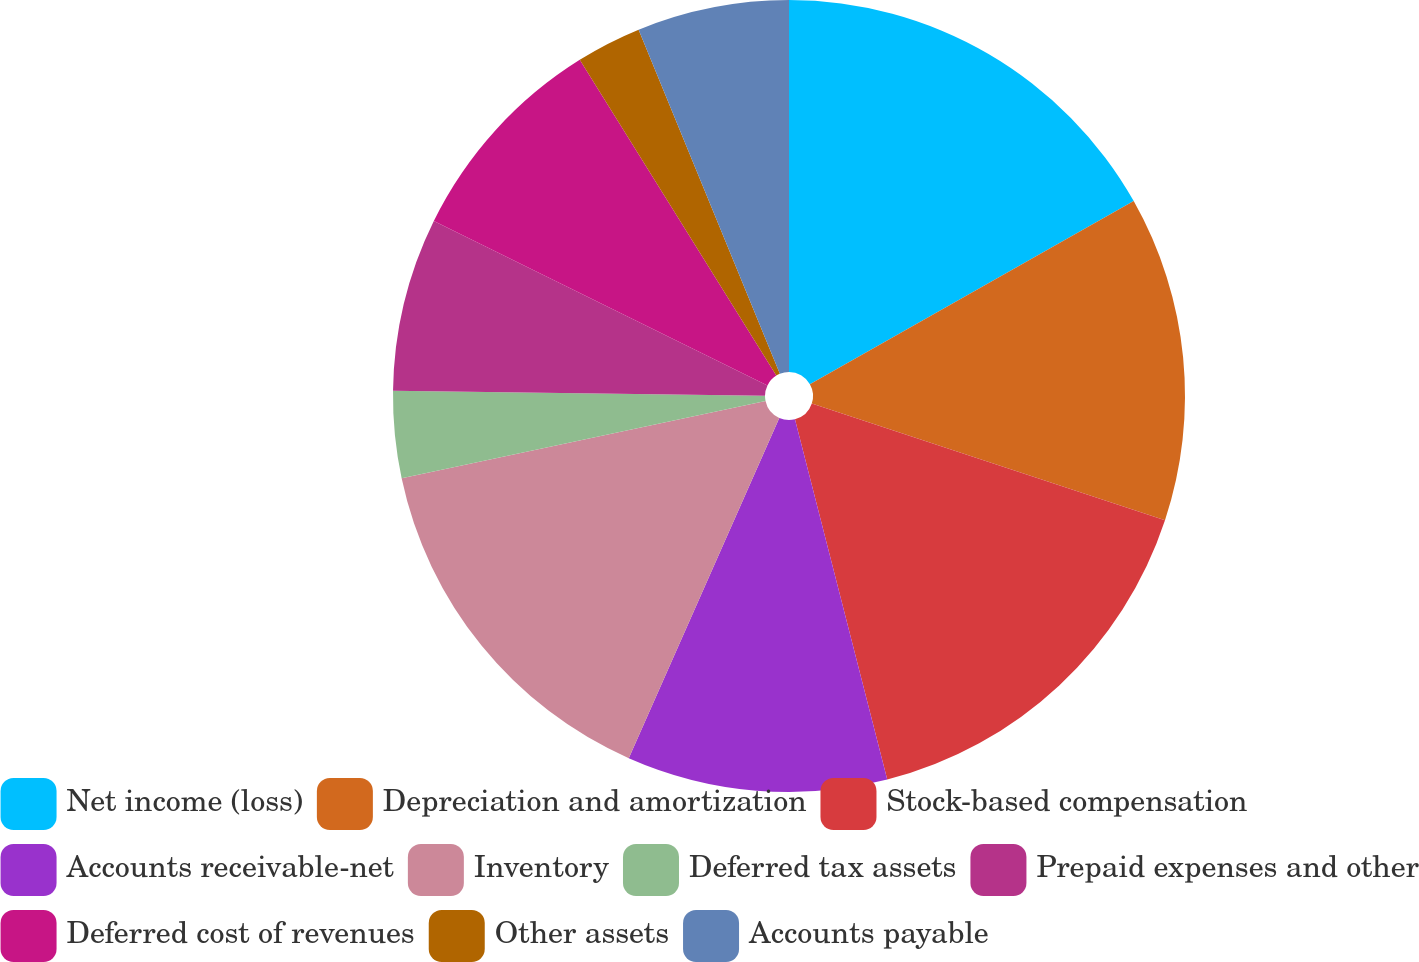Convert chart. <chart><loc_0><loc_0><loc_500><loc_500><pie_chart><fcel>Net income (loss)<fcel>Depreciation and amortization<fcel>Stock-based compensation<fcel>Accounts receivable-net<fcel>Inventory<fcel>Deferred tax assets<fcel>Prepaid expenses and other<fcel>Deferred cost of revenues<fcel>Other assets<fcel>Accounts payable<nl><fcel>16.81%<fcel>13.27%<fcel>15.93%<fcel>10.62%<fcel>15.04%<fcel>3.54%<fcel>7.08%<fcel>8.85%<fcel>2.66%<fcel>6.2%<nl></chart> 